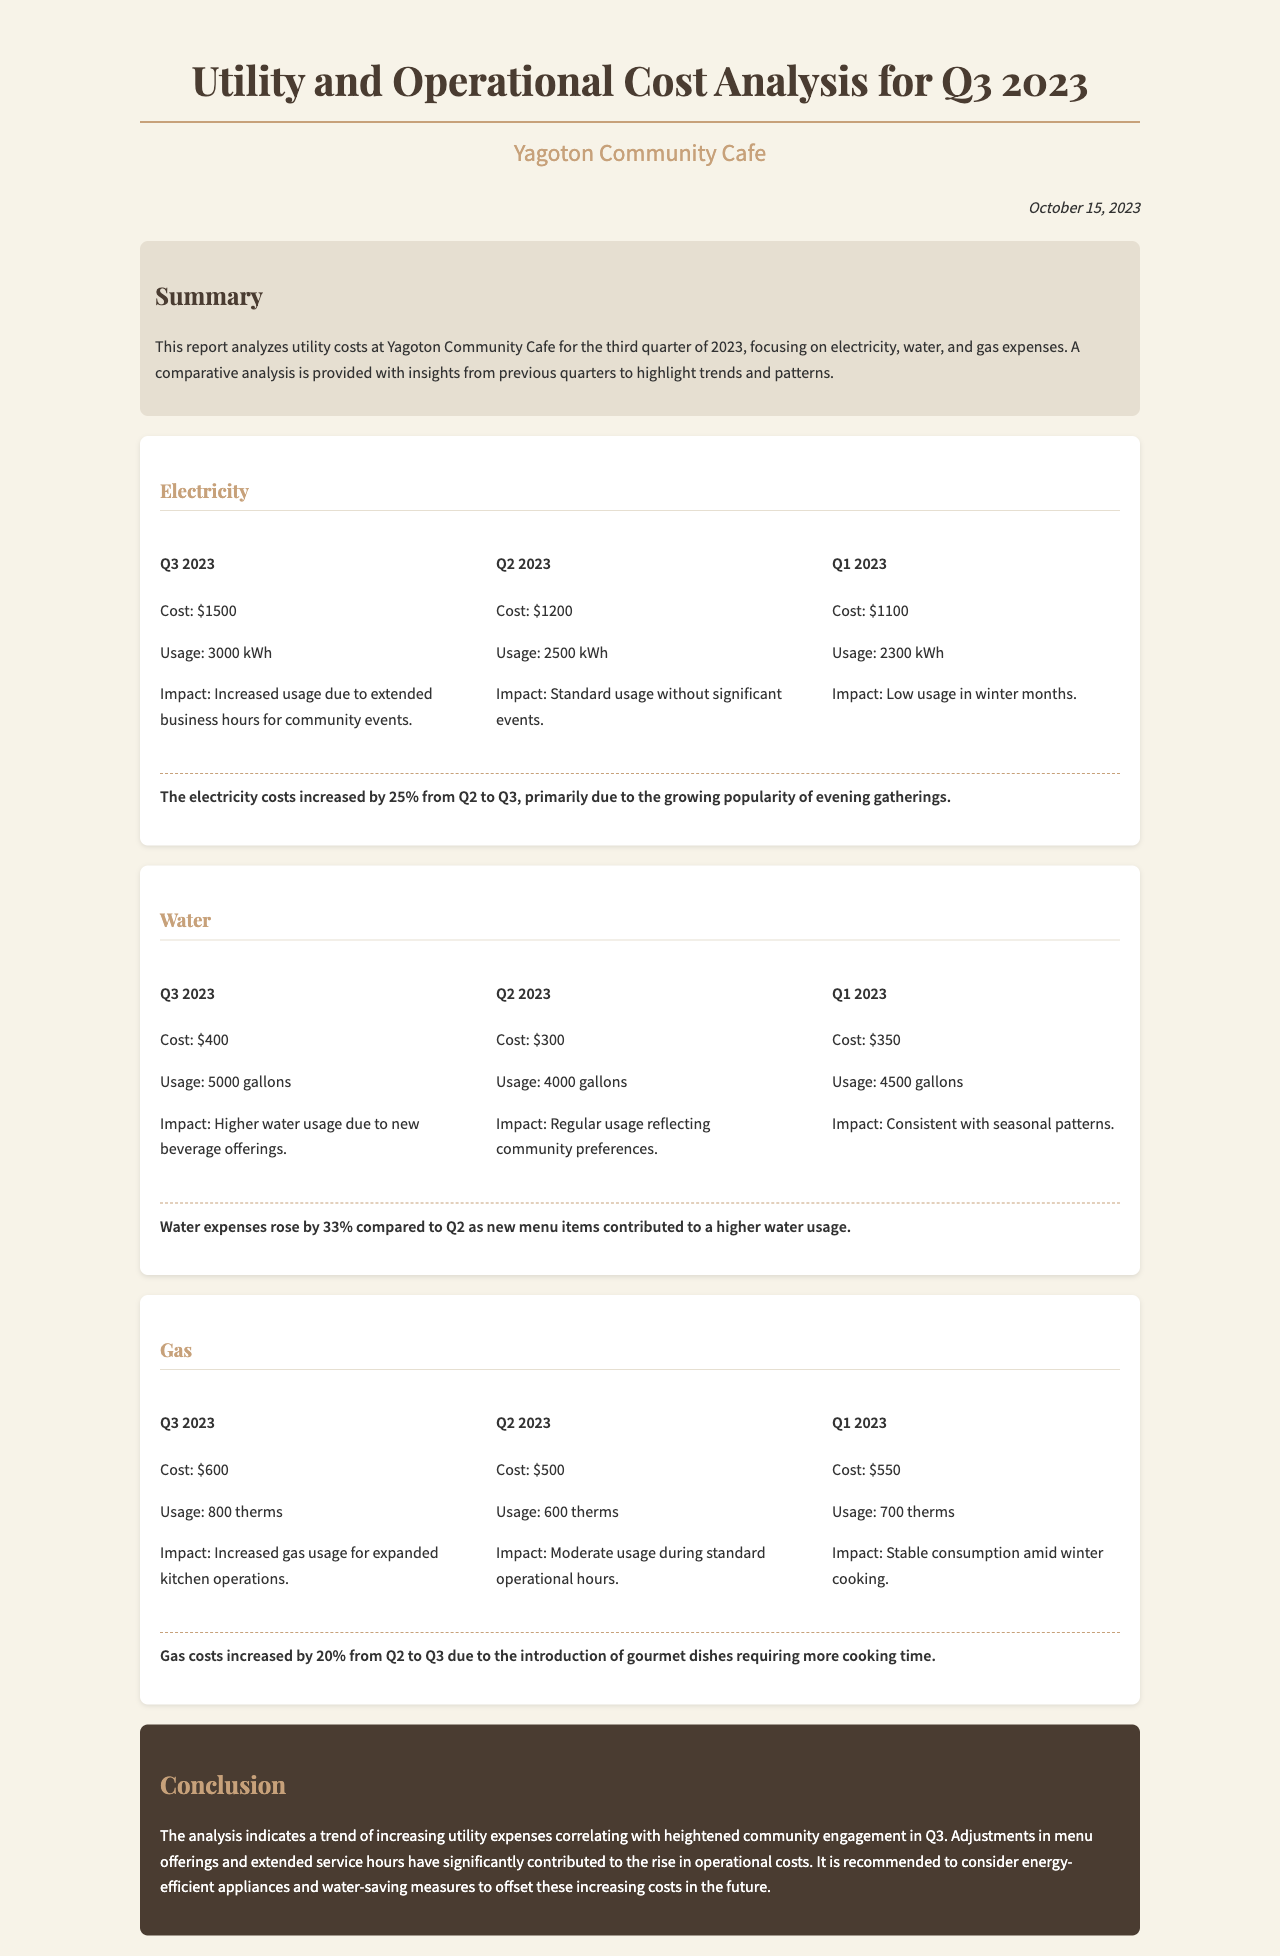What was the electricity cost in Q3 2023? The electricity cost for Q3 2023 is detailed in the document under the Electricity section.
Answer: $1500 What was the water usage in Q2 2023? The water usage for Q2 2023 is specified in the Water section of the document.
Answer: 4000 gallons What was the percentage increase in gas costs from Q2 to Q3? The comparison in the Gas section indicates the percentage increase in costs from Q2 to Q3.
Answer: 20% What impact contributed to the increased electricity usage in Q3 2023? The document states that the increased usage was due to extended business hours for community events.
Answer: Extended business hours What is the total cost for water in Q3 2023? The total cost for water in Q3 2023 is mentioned in the Water section.
Answer: $400 What was the cost for gas in Q1 2023? The cost for gas in Q1 2023 can be found in the Gas section of the report.
Answer: $550 What trend is indicated by the utility analysis for Q3 2023? The conclusion summarizes the trends highlighted throughout the report.
Answer: Increasing utility expenses How many kilowatt-hours were used in Q3 2023? The usage for electricity in Q3 2023 is specified in the Electricity section.
Answer: 3000 kWh What recommendation is made in the conclusion to offset rising costs? The conclusion includes a recommendation aimed at addressing the rising operational costs.
Answer: Energy-efficient appliances 